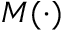Convert formula to latex. <formula><loc_0><loc_0><loc_500><loc_500>M ( \cdot )</formula> 